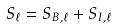<formula> <loc_0><loc_0><loc_500><loc_500>\ S _ { \ell } = S _ { B , \ell } + S _ { I , \ell }</formula> 